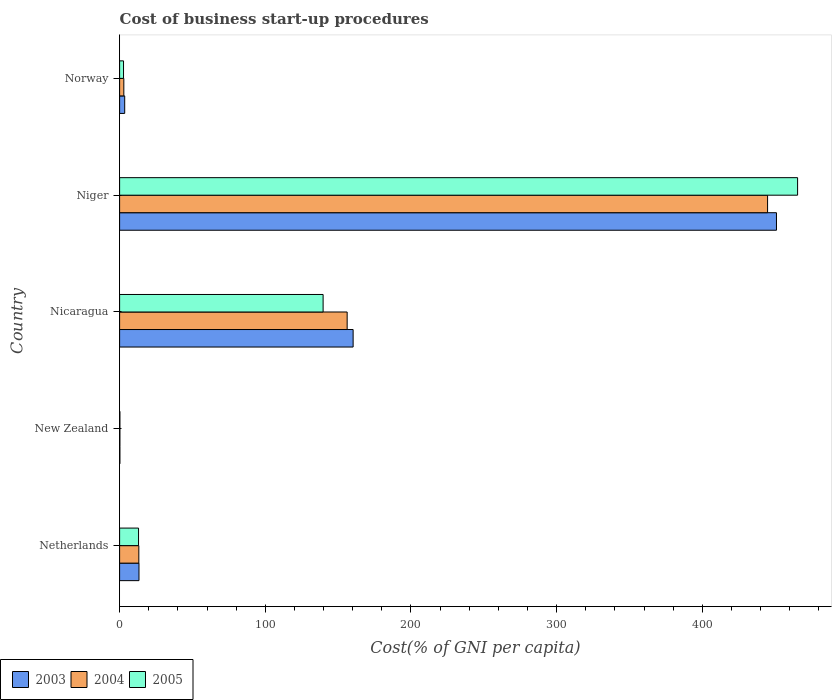What is the label of the 2nd group of bars from the top?
Offer a terse response. Niger. What is the cost of business start-up procedures in 2005 in New Zealand?
Provide a succinct answer. 0.2. Across all countries, what is the maximum cost of business start-up procedures in 2004?
Provide a succinct answer. 444.8. In which country was the cost of business start-up procedures in 2004 maximum?
Give a very brief answer. Niger. In which country was the cost of business start-up procedures in 2003 minimum?
Provide a succinct answer. New Zealand. What is the total cost of business start-up procedures in 2003 in the graph?
Your response must be concise. 628.2. What is the difference between the cost of business start-up procedures in 2003 in New Zealand and that in Niger?
Your answer should be very brief. -450.7. What is the difference between the cost of business start-up procedures in 2005 in Netherlands and the cost of business start-up procedures in 2004 in Niger?
Make the answer very short. -431.8. What is the average cost of business start-up procedures in 2003 per country?
Your answer should be compact. 125.64. What is the difference between the cost of business start-up procedures in 2003 and cost of business start-up procedures in 2005 in Netherlands?
Offer a very short reply. 0.3. What is the ratio of the cost of business start-up procedures in 2005 in Netherlands to that in New Zealand?
Give a very brief answer. 65. Is the cost of business start-up procedures in 2004 in New Zealand less than that in Nicaragua?
Keep it short and to the point. Yes. What is the difference between the highest and the second highest cost of business start-up procedures in 2005?
Make the answer very short. 325.7. What is the difference between the highest and the lowest cost of business start-up procedures in 2004?
Your response must be concise. 444.6. In how many countries, is the cost of business start-up procedures in 2005 greater than the average cost of business start-up procedures in 2005 taken over all countries?
Make the answer very short. 2. Is the sum of the cost of business start-up procedures in 2004 in Netherlands and New Zealand greater than the maximum cost of business start-up procedures in 2005 across all countries?
Keep it short and to the point. No. What does the 2nd bar from the top in Nicaragua represents?
Make the answer very short. 2004. What does the 3rd bar from the bottom in Niger represents?
Ensure brevity in your answer.  2005. Is it the case that in every country, the sum of the cost of business start-up procedures in 2005 and cost of business start-up procedures in 2004 is greater than the cost of business start-up procedures in 2003?
Offer a terse response. Yes. How many bars are there?
Make the answer very short. 15. What is the difference between two consecutive major ticks on the X-axis?
Provide a short and direct response. 100. Are the values on the major ticks of X-axis written in scientific E-notation?
Make the answer very short. No. Does the graph contain any zero values?
Keep it short and to the point. No. How many legend labels are there?
Provide a succinct answer. 3. How are the legend labels stacked?
Keep it short and to the point. Horizontal. What is the title of the graph?
Provide a short and direct response. Cost of business start-up procedures. What is the label or title of the X-axis?
Ensure brevity in your answer.  Cost(% of GNI per capita). What is the Cost(% of GNI per capita) of 2003 in Netherlands?
Provide a short and direct response. 13.3. What is the Cost(% of GNI per capita) in 2005 in Netherlands?
Offer a very short reply. 13. What is the Cost(% of GNI per capita) in 2003 in New Zealand?
Provide a short and direct response. 0.2. What is the Cost(% of GNI per capita) of 2003 in Nicaragua?
Ensure brevity in your answer.  160.3. What is the Cost(% of GNI per capita) in 2004 in Nicaragua?
Provide a succinct answer. 156.2. What is the Cost(% of GNI per capita) of 2005 in Nicaragua?
Make the answer very short. 139.7. What is the Cost(% of GNI per capita) of 2003 in Niger?
Your answer should be compact. 450.9. What is the Cost(% of GNI per capita) in 2004 in Niger?
Offer a terse response. 444.8. What is the Cost(% of GNI per capita) in 2005 in Niger?
Give a very brief answer. 465.4. What is the Cost(% of GNI per capita) of 2004 in Norway?
Provide a short and direct response. 2.9. What is the Cost(% of GNI per capita) of 2005 in Norway?
Your response must be concise. 2.7. Across all countries, what is the maximum Cost(% of GNI per capita) in 2003?
Ensure brevity in your answer.  450.9. Across all countries, what is the maximum Cost(% of GNI per capita) of 2004?
Keep it short and to the point. 444.8. Across all countries, what is the maximum Cost(% of GNI per capita) of 2005?
Your response must be concise. 465.4. Across all countries, what is the minimum Cost(% of GNI per capita) in 2003?
Give a very brief answer. 0.2. Across all countries, what is the minimum Cost(% of GNI per capita) in 2004?
Keep it short and to the point. 0.2. What is the total Cost(% of GNI per capita) of 2003 in the graph?
Your response must be concise. 628.2. What is the total Cost(% of GNI per capita) in 2004 in the graph?
Your response must be concise. 617.3. What is the total Cost(% of GNI per capita) in 2005 in the graph?
Your answer should be very brief. 621. What is the difference between the Cost(% of GNI per capita) of 2003 in Netherlands and that in New Zealand?
Your answer should be compact. 13.1. What is the difference between the Cost(% of GNI per capita) of 2005 in Netherlands and that in New Zealand?
Give a very brief answer. 12.8. What is the difference between the Cost(% of GNI per capita) of 2003 in Netherlands and that in Nicaragua?
Your answer should be compact. -147. What is the difference between the Cost(% of GNI per capita) in 2004 in Netherlands and that in Nicaragua?
Offer a terse response. -143. What is the difference between the Cost(% of GNI per capita) of 2005 in Netherlands and that in Nicaragua?
Ensure brevity in your answer.  -126.7. What is the difference between the Cost(% of GNI per capita) of 2003 in Netherlands and that in Niger?
Make the answer very short. -437.6. What is the difference between the Cost(% of GNI per capita) of 2004 in Netherlands and that in Niger?
Make the answer very short. -431.6. What is the difference between the Cost(% of GNI per capita) of 2005 in Netherlands and that in Niger?
Provide a succinct answer. -452.4. What is the difference between the Cost(% of GNI per capita) in 2004 in Netherlands and that in Norway?
Provide a short and direct response. 10.3. What is the difference between the Cost(% of GNI per capita) in 2003 in New Zealand and that in Nicaragua?
Offer a very short reply. -160.1. What is the difference between the Cost(% of GNI per capita) of 2004 in New Zealand and that in Nicaragua?
Offer a terse response. -156. What is the difference between the Cost(% of GNI per capita) of 2005 in New Zealand and that in Nicaragua?
Your answer should be very brief. -139.5. What is the difference between the Cost(% of GNI per capita) of 2003 in New Zealand and that in Niger?
Your answer should be very brief. -450.7. What is the difference between the Cost(% of GNI per capita) of 2004 in New Zealand and that in Niger?
Make the answer very short. -444.6. What is the difference between the Cost(% of GNI per capita) of 2005 in New Zealand and that in Niger?
Ensure brevity in your answer.  -465.2. What is the difference between the Cost(% of GNI per capita) in 2003 in New Zealand and that in Norway?
Make the answer very short. -3.3. What is the difference between the Cost(% of GNI per capita) in 2004 in New Zealand and that in Norway?
Keep it short and to the point. -2.7. What is the difference between the Cost(% of GNI per capita) in 2003 in Nicaragua and that in Niger?
Make the answer very short. -290.6. What is the difference between the Cost(% of GNI per capita) of 2004 in Nicaragua and that in Niger?
Give a very brief answer. -288.6. What is the difference between the Cost(% of GNI per capita) of 2005 in Nicaragua and that in Niger?
Your answer should be very brief. -325.7. What is the difference between the Cost(% of GNI per capita) of 2003 in Nicaragua and that in Norway?
Offer a terse response. 156.8. What is the difference between the Cost(% of GNI per capita) of 2004 in Nicaragua and that in Norway?
Your answer should be compact. 153.3. What is the difference between the Cost(% of GNI per capita) in 2005 in Nicaragua and that in Norway?
Keep it short and to the point. 137. What is the difference between the Cost(% of GNI per capita) of 2003 in Niger and that in Norway?
Your answer should be compact. 447.4. What is the difference between the Cost(% of GNI per capita) in 2004 in Niger and that in Norway?
Your answer should be very brief. 441.9. What is the difference between the Cost(% of GNI per capita) in 2005 in Niger and that in Norway?
Make the answer very short. 462.7. What is the difference between the Cost(% of GNI per capita) in 2003 in Netherlands and the Cost(% of GNI per capita) in 2005 in New Zealand?
Ensure brevity in your answer.  13.1. What is the difference between the Cost(% of GNI per capita) in 2003 in Netherlands and the Cost(% of GNI per capita) in 2004 in Nicaragua?
Make the answer very short. -142.9. What is the difference between the Cost(% of GNI per capita) in 2003 in Netherlands and the Cost(% of GNI per capita) in 2005 in Nicaragua?
Your answer should be very brief. -126.4. What is the difference between the Cost(% of GNI per capita) of 2004 in Netherlands and the Cost(% of GNI per capita) of 2005 in Nicaragua?
Provide a short and direct response. -126.5. What is the difference between the Cost(% of GNI per capita) of 2003 in Netherlands and the Cost(% of GNI per capita) of 2004 in Niger?
Your answer should be very brief. -431.5. What is the difference between the Cost(% of GNI per capita) in 2003 in Netherlands and the Cost(% of GNI per capita) in 2005 in Niger?
Your answer should be very brief. -452.1. What is the difference between the Cost(% of GNI per capita) of 2004 in Netherlands and the Cost(% of GNI per capita) of 2005 in Niger?
Ensure brevity in your answer.  -452.2. What is the difference between the Cost(% of GNI per capita) of 2003 in New Zealand and the Cost(% of GNI per capita) of 2004 in Nicaragua?
Offer a terse response. -156. What is the difference between the Cost(% of GNI per capita) of 2003 in New Zealand and the Cost(% of GNI per capita) of 2005 in Nicaragua?
Make the answer very short. -139.5. What is the difference between the Cost(% of GNI per capita) in 2004 in New Zealand and the Cost(% of GNI per capita) in 2005 in Nicaragua?
Make the answer very short. -139.5. What is the difference between the Cost(% of GNI per capita) in 2003 in New Zealand and the Cost(% of GNI per capita) in 2004 in Niger?
Keep it short and to the point. -444.6. What is the difference between the Cost(% of GNI per capita) in 2003 in New Zealand and the Cost(% of GNI per capita) in 2005 in Niger?
Give a very brief answer. -465.2. What is the difference between the Cost(% of GNI per capita) in 2004 in New Zealand and the Cost(% of GNI per capita) in 2005 in Niger?
Provide a short and direct response. -465.2. What is the difference between the Cost(% of GNI per capita) in 2003 in Nicaragua and the Cost(% of GNI per capita) in 2004 in Niger?
Your answer should be very brief. -284.5. What is the difference between the Cost(% of GNI per capita) in 2003 in Nicaragua and the Cost(% of GNI per capita) in 2005 in Niger?
Keep it short and to the point. -305.1. What is the difference between the Cost(% of GNI per capita) in 2004 in Nicaragua and the Cost(% of GNI per capita) in 2005 in Niger?
Offer a very short reply. -309.2. What is the difference between the Cost(% of GNI per capita) of 2003 in Nicaragua and the Cost(% of GNI per capita) of 2004 in Norway?
Your response must be concise. 157.4. What is the difference between the Cost(% of GNI per capita) of 2003 in Nicaragua and the Cost(% of GNI per capita) of 2005 in Norway?
Your response must be concise. 157.6. What is the difference between the Cost(% of GNI per capita) in 2004 in Nicaragua and the Cost(% of GNI per capita) in 2005 in Norway?
Offer a terse response. 153.5. What is the difference between the Cost(% of GNI per capita) in 2003 in Niger and the Cost(% of GNI per capita) in 2004 in Norway?
Provide a succinct answer. 448. What is the difference between the Cost(% of GNI per capita) of 2003 in Niger and the Cost(% of GNI per capita) of 2005 in Norway?
Your answer should be very brief. 448.2. What is the difference between the Cost(% of GNI per capita) of 2004 in Niger and the Cost(% of GNI per capita) of 2005 in Norway?
Your answer should be very brief. 442.1. What is the average Cost(% of GNI per capita) of 2003 per country?
Offer a very short reply. 125.64. What is the average Cost(% of GNI per capita) in 2004 per country?
Make the answer very short. 123.46. What is the average Cost(% of GNI per capita) of 2005 per country?
Keep it short and to the point. 124.2. What is the difference between the Cost(% of GNI per capita) of 2003 and Cost(% of GNI per capita) of 2004 in Netherlands?
Provide a succinct answer. 0.1. What is the difference between the Cost(% of GNI per capita) in 2003 and Cost(% of GNI per capita) in 2005 in Netherlands?
Your response must be concise. 0.3. What is the difference between the Cost(% of GNI per capita) in 2003 and Cost(% of GNI per capita) in 2005 in New Zealand?
Offer a very short reply. 0. What is the difference between the Cost(% of GNI per capita) in 2003 and Cost(% of GNI per capita) in 2004 in Nicaragua?
Give a very brief answer. 4.1. What is the difference between the Cost(% of GNI per capita) in 2003 and Cost(% of GNI per capita) in 2005 in Nicaragua?
Provide a succinct answer. 20.6. What is the difference between the Cost(% of GNI per capita) in 2003 and Cost(% of GNI per capita) in 2004 in Niger?
Offer a terse response. 6.1. What is the difference between the Cost(% of GNI per capita) in 2004 and Cost(% of GNI per capita) in 2005 in Niger?
Make the answer very short. -20.6. What is the difference between the Cost(% of GNI per capita) of 2003 and Cost(% of GNI per capita) of 2004 in Norway?
Your answer should be very brief. 0.6. What is the difference between the Cost(% of GNI per capita) in 2004 and Cost(% of GNI per capita) in 2005 in Norway?
Offer a terse response. 0.2. What is the ratio of the Cost(% of GNI per capita) in 2003 in Netherlands to that in New Zealand?
Your answer should be compact. 66.5. What is the ratio of the Cost(% of GNI per capita) of 2005 in Netherlands to that in New Zealand?
Keep it short and to the point. 65. What is the ratio of the Cost(% of GNI per capita) in 2003 in Netherlands to that in Nicaragua?
Your answer should be very brief. 0.08. What is the ratio of the Cost(% of GNI per capita) in 2004 in Netherlands to that in Nicaragua?
Ensure brevity in your answer.  0.08. What is the ratio of the Cost(% of GNI per capita) in 2005 in Netherlands to that in Nicaragua?
Provide a short and direct response. 0.09. What is the ratio of the Cost(% of GNI per capita) of 2003 in Netherlands to that in Niger?
Your answer should be very brief. 0.03. What is the ratio of the Cost(% of GNI per capita) in 2004 in Netherlands to that in Niger?
Ensure brevity in your answer.  0.03. What is the ratio of the Cost(% of GNI per capita) of 2005 in Netherlands to that in Niger?
Give a very brief answer. 0.03. What is the ratio of the Cost(% of GNI per capita) in 2004 in Netherlands to that in Norway?
Provide a short and direct response. 4.55. What is the ratio of the Cost(% of GNI per capita) of 2005 in Netherlands to that in Norway?
Your answer should be compact. 4.81. What is the ratio of the Cost(% of GNI per capita) of 2003 in New Zealand to that in Nicaragua?
Offer a very short reply. 0. What is the ratio of the Cost(% of GNI per capita) in 2004 in New Zealand to that in Nicaragua?
Your answer should be very brief. 0. What is the ratio of the Cost(% of GNI per capita) of 2005 in New Zealand to that in Nicaragua?
Give a very brief answer. 0. What is the ratio of the Cost(% of GNI per capita) in 2003 in New Zealand to that in Norway?
Provide a short and direct response. 0.06. What is the ratio of the Cost(% of GNI per capita) of 2004 in New Zealand to that in Norway?
Ensure brevity in your answer.  0.07. What is the ratio of the Cost(% of GNI per capita) of 2005 in New Zealand to that in Norway?
Offer a very short reply. 0.07. What is the ratio of the Cost(% of GNI per capita) in 2003 in Nicaragua to that in Niger?
Make the answer very short. 0.36. What is the ratio of the Cost(% of GNI per capita) of 2004 in Nicaragua to that in Niger?
Offer a terse response. 0.35. What is the ratio of the Cost(% of GNI per capita) in 2005 in Nicaragua to that in Niger?
Your answer should be compact. 0.3. What is the ratio of the Cost(% of GNI per capita) in 2003 in Nicaragua to that in Norway?
Give a very brief answer. 45.8. What is the ratio of the Cost(% of GNI per capita) in 2004 in Nicaragua to that in Norway?
Offer a very short reply. 53.86. What is the ratio of the Cost(% of GNI per capita) in 2005 in Nicaragua to that in Norway?
Your answer should be very brief. 51.74. What is the ratio of the Cost(% of GNI per capita) of 2003 in Niger to that in Norway?
Your answer should be very brief. 128.83. What is the ratio of the Cost(% of GNI per capita) of 2004 in Niger to that in Norway?
Provide a short and direct response. 153.38. What is the ratio of the Cost(% of GNI per capita) in 2005 in Niger to that in Norway?
Provide a short and direct response. 172.37. What is the difference between the highest and the second highest Cost(% of GNI per capita) of 2003?
Make the answer very short. 290.6. What is the difference between the highest and the second highest Cost(% of GNI per capita) in 2004?
Offer a terse response. 288.6. What is the difference between the highest and the second highest Cost(% of GNI per capita) in 2005?
Provide a succinct answer. 325.7. What is the difference between the highest and the lowest Cost(% of GNI per capita) in 2003?
Make the answer very short. 450.7. What is the difference between the highest and the lowest Cost(% of GNI per capita) in 2004?
Provide a short and direct response. 444.6. What is the difference between the highest and the lowest Cost(% of GNI per capita) of 2005?
Give a very brief answer. 465.2. 